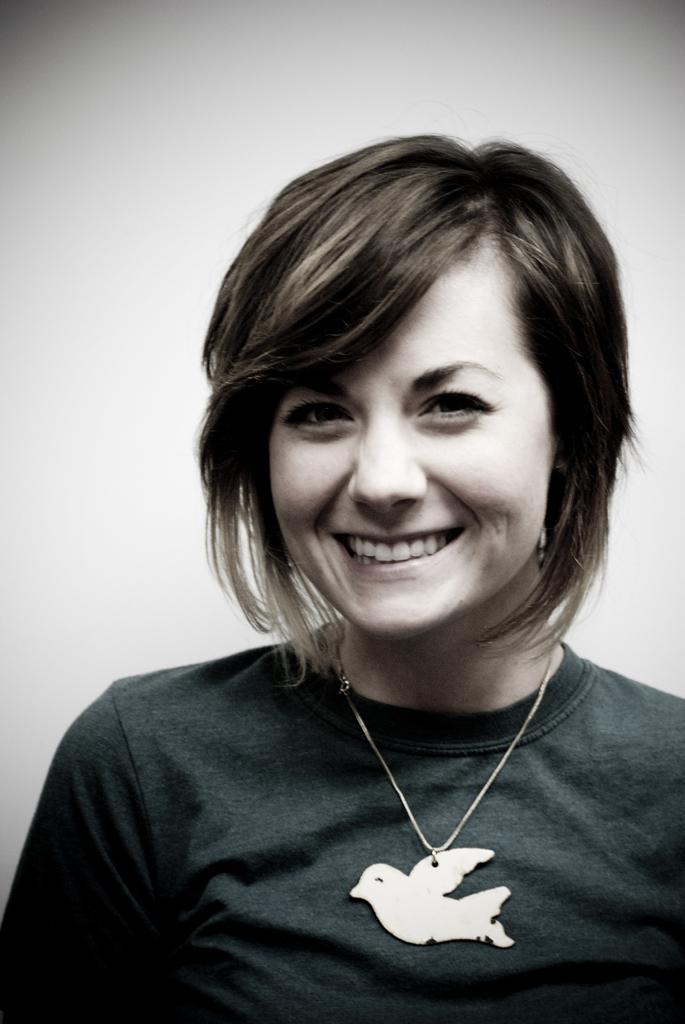How would you summarize this image in a sentence or two? In this image we can see a woman wearing a locket. On the backside we can see a wall. 